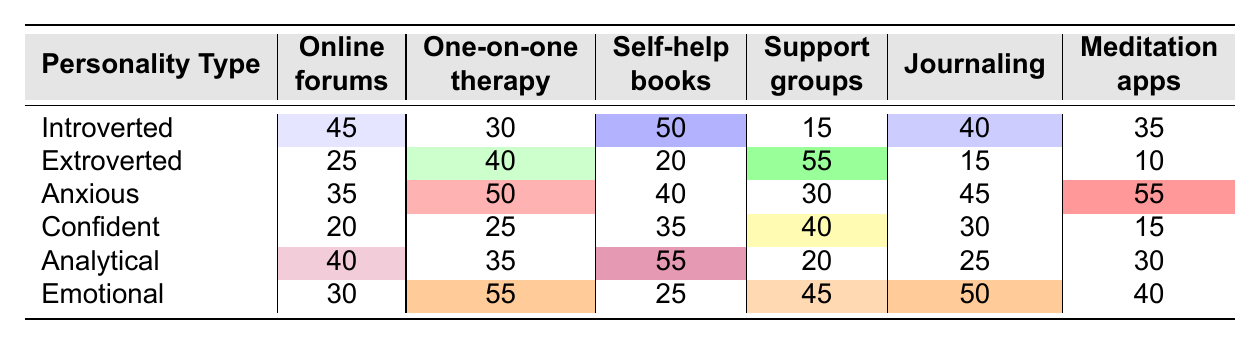What support method is most preferred by introverted individuals? According to the table, introverted individuals prefer self-help books the most with a score of 50.
Answer: Self-help books Which support method do extroverted individuals prefer the least? The table shows that extroverted individuals prefer meditation apps the least with a score of 10.
Answer: Meditation apps What is the total number of individuals across all personality types who prefer journaling? The total for journaling can be found by adding the values: 40 (Introverted) + 15 (Extroverted) + 45 (Anxious) + 30 (Confident) + 25 (Analytical) + 50 (Emotional) = 205.
Answer: 205 Is online forums the most preferred support method by any personality type? The highest score for online forums is 45 (by introverted individuals), but there are other methods with higher scores, so it is not the most preferred by any type.
Answer: No What is the difference in preference for one-on-one therapy between anxious and emotional individuals? The score for anxious individuals is 50 and for emotional individuals is 55. The difference is calculated as 55 - 50 = 5.
Answer: 5 What support methods do analytical individuals prefer more than 50? The only method preferred by analytical individuals more than 50 is self-help books, which scored 55.
Answer: Self-help books For which personality type is journaling the most preferred support method? Emotional individuals have the highest score for journaling at 50.
Answer: Emotional What is the average score for support groups across all personality types? To calculate the average for support groups, sum the scores: 15 (Introverted) + 55 (Extroverted) + 30 (Anxious) + 40 (Confident) + 20 (Analytical) + 45 (Emotional) = 205, then divide by the number of personality types, which is 6. Average = 205 / 6 = approximately 34.17.
Answer: Approximately 34.17 Which personality type has the highest preference for meditation apps? Anxious individuals have the highest preference for meditation apps at 55.
Answer: Anxious Which support method is the least preferred by both extroverted and analytical personality types? Extroverted individuals least prefer meditation apps (10), while analytical individuals score 30 on meditation apps. The least preferred method for extroverted individuals is lower than analytical, confirming that meditation apps rank lowest for extroverted types.
Answer: Meditation apps 